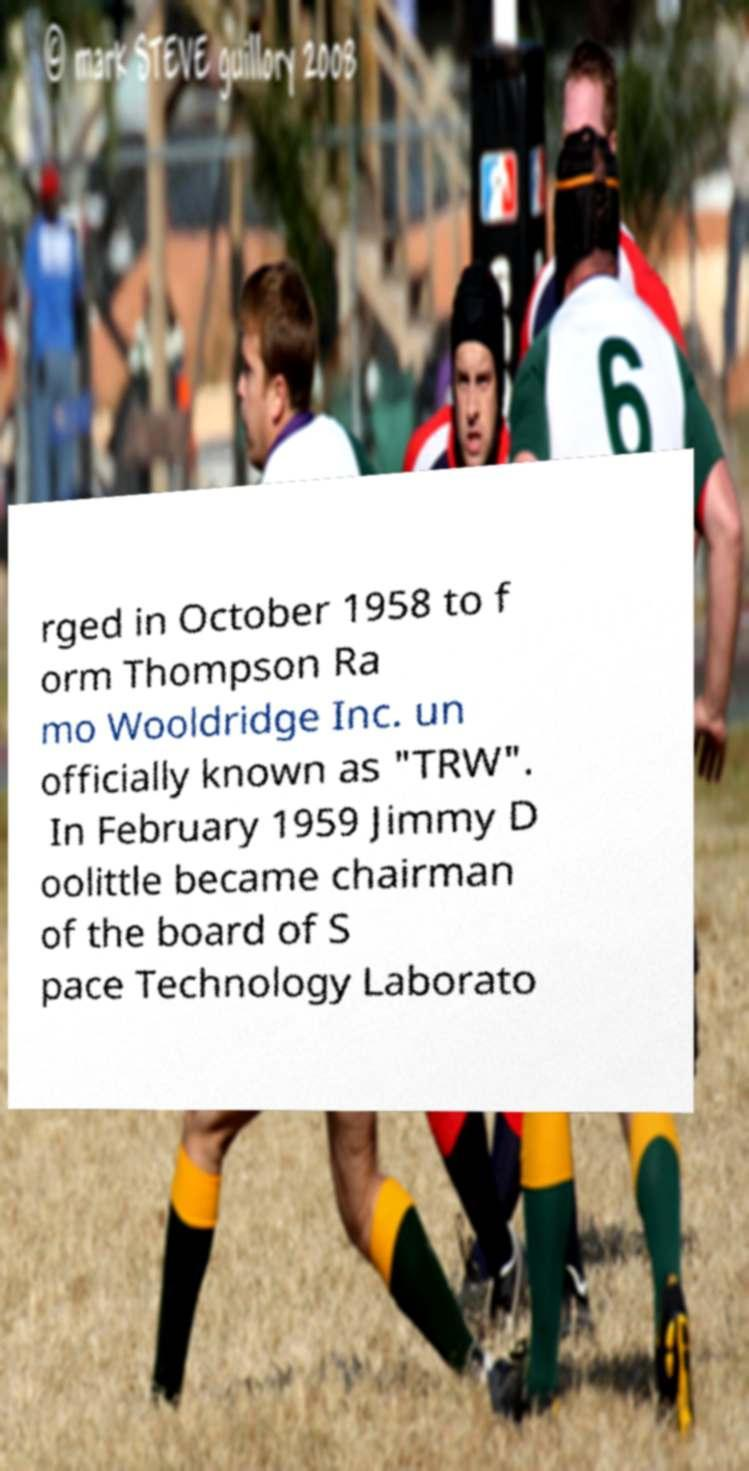Could you extract and type out the text from this image? rged in October 1958 to f orm Thompson Ra mo Wooldridge Inc. un officially known as "TRW". In February 1959 Jimmy D oolittle became chairman of the board of S pace Technology Laborato 